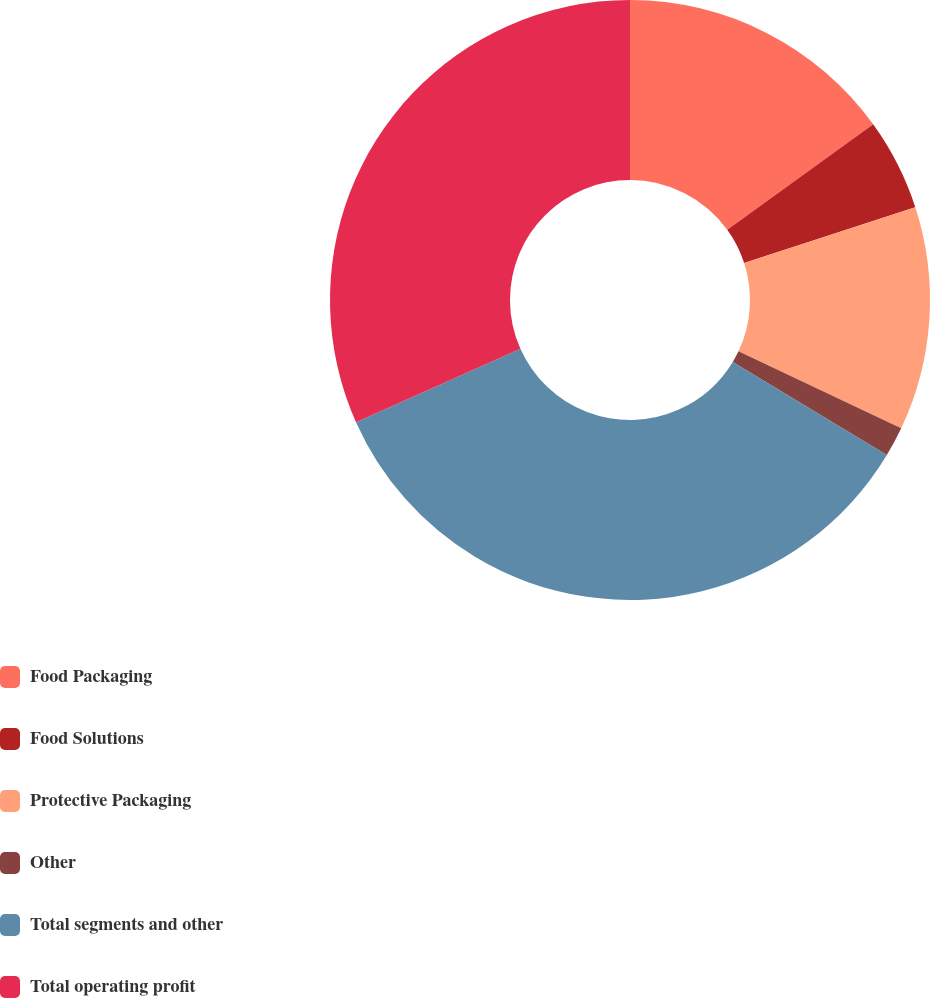<chart> <loc_0><loc_0><loc_500><loc_500><pie_chart><fcel>Food Packaging<fcel>Food Solutions<fcel>Protective Packaging<fcel>Other<fcel>Total segments and other<fcel>Total operating profit<nl><fcel>15.04%<fcel>4.96%<fcel>12.03%<fcel>1.61%<fcel>34.68%<fcel>31.67%<nl></chart> 